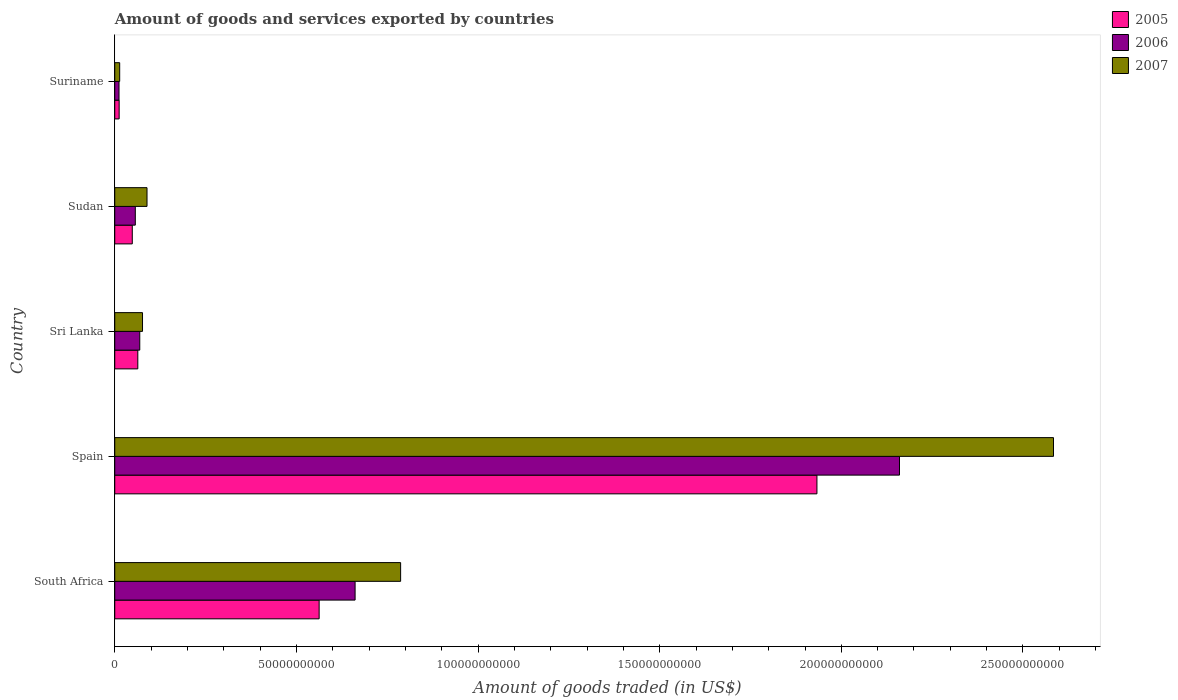How many different coloured bars are there?
Offer a very short reply. 3. Are the number of bars per tick equal to the number of legend labels?
Offer a terse response. Yes. Are the number of bars on each tick of the Y-axis equal?
Make the answer very short. Yes. What is the label of the 4th group of bars from the top?
Your response must be concise. Spain. In how many cases, is the number of bars for a given country not equal to the number of legend labels?
Your answer should be compact. 0. What is the total amount of goods and services exported in 2007 in Spain?
Provide a short and direct response. 2.58e+11. Across all countries, what is the maximum total amount of goods and services exported in 2007?
Provide a succinct answer. 2.58e+11. Across all countries, what is the minimum total amount of goods and services exported in 2006?
Offer a very short reply. 1.17e+09. In which country was the total amount of goods and services exported in 2005 minimum?
Provide a succinct answer. Suriname. What is the total total amount of goods and services exported in 2006 in the graph?
Provide a succinct answer. 2.96e+11. What is the difference between the total amount of goods and services exported in 2006 in Sri Lanka and that in Suriname?
Your answer should be compact. 5.71e+09. What is the difference between the total amount of goods and services exported in 2005 in South Africa and the total amount of goods and services exported in 2007 in Suriname?
Keep it short and to the point. 5.49e+1. What is the average total amount of goods and services exported in 2007 per country?
Make the answer very short. 7.10e+1. What is the difference between the total amount of goods and services exported in 2005 and total amount of goods and services exported in 2007 in Suriname?
Ensure brevity in your answer.  -1.48e+08. What is the ratio of the total amount of goods and services exported in 2007 in South Africa to that in Suriname?
Provide a short and direct response. 57.9. Is the difference between the total amount of goods and services exported in 2005 in Sri Lanka and Suriname greater than the difference between the total amount of goods and services exported in 2007 in Sri Lanka and Suriname?
Provide a short and direct response. No. What is the difference between the highest and the second highest total amount of goods and services exported in 2007?
Your answer should be very brief. 1.80e+11. What is the difference between the highest and the lowest total amount of goods and services exported in 2005?
Provide a succinct answer. 1.92e+11. Is the sum of the total amount of goods and services exported in 2007 in Spain and Suriname greater than the maximum total amount of goods and services exported in 2005 across all countries?
Provide a short and direct response. Yes. What does the 3rd bar from the top in Suriname represents?
Provide a succinct answer. 2005. What does the 2nd bar from the bottom in Sudan represents?
Your answer should be compact. 2006. Is it the case that in every country, the sum of the total amount of goods and services exported in 2007 and total amount of goods and services exported in 2006 is greater than the total amount of goods and services exported in 2005?
Provide a succinct answer. Yes. Are all the bars in the graph horizontal?
Provide a succinct answer. Yes. How many countries are there in the graph?
Your answer should be compact. 5. What is the difference between two consecutive major ticks on the X-axis?
Ensure brevity in your answer.  5.00e+1. Are the values on the major ticks of X-axis written in scientific E-notation?
Offer a very short reply. No. Where does the legend appear in the graph?
Keep it short and to the point. Top right. How are the legend labels stacked?
Provide a succinct answer. Vertical. What is the title of the graph?
Make the answer very short. Amount of goods and services exported by countries. What is the label or title of the X-axis?
Offer a very short reply. Amount of goods traded (in US$). What is the Amount of goods traded (in US$) of 2005 in South Africa?
Your answer should be compact. 5.63e+1. What is the Amount of goods traded (in US$) in 2006 in South Africa?
Offer a terse response. 6.62e+1. What is the Amount of goods traded (in US$) of 2007 in South Africa?
Provide a succinct answer. 7.87e+1. What is the Amount of goods traded (in US$) in 2005 in Spain?
Ensure brevity in your answer.  1.93e+11. What is the Amount of goods traded (in US$) in 2006 in Spain?
Keep it short and to the point. 2.16e+11. What is the Amount of goods traded (in US$) of 2007 in Spain?
Your answer should be very brief. 2.58e+11. What is the Amount of goods traded (in US$) in 2005 in Sri Lanka?
Your answer should be very brief. 6.35e+09. What is the Amount of goods traded (in US$) of 2006 in Sri Lanka?
Your answer should be compact. 6.88e+09. What is the Amount of goods traded (in US$) of 2007 in Sri Lanka?
Your answer should be compact. 7.64e+09. What is the Amount of goods traded (in US$) of 2005 in Sudan?
Keep it short and to the point. 4.82e+09. What is the Amount of goods traded (in US$) in 2006 in Sudan?
Your answer should be very brief. 5.66e+09. What is the Amount of goods traded (in US$) of 2007 in Sudan?
Your answer should be very brief. 8.88e+09. What is the Amount of goods traded (in US$) of 2005 in Suriname?
Offer a terse response. 1.21e+09. What is the Amount of goods traded (in US$) of 2006 in Suriname?
Your answer should be compact. 1.17e+09. What is the Amount of goods traded (in US$) of 2007 in Suriname?
Give a very brief answer. 1.36e+09. Across all countries, what is the maximum Amount of goods traded (in US$) in 2005?
Your answer should be compact. 1.93e+11. Across all countries, what is the maximum Amount of goods traded (in US$) of 2006?
Ensure brevity in your answer.  2.16e+11. Across all countries, what is the maximum Amount of goods traded (in US$) in 2007?
Ensure brevity in your answer.  2.58e+11. Across all countries, what is the minimum Amount of goods traded (in US$) of 2005?
Keep it short and to the point. 1.21e+09. Across all countries, what is the minimum Amount of goods traded (in US$) in 2006?
Ensure brevity in your answer.  1.17e+09. Across all countries, what is the minimum Amount of goods traded (in US$) of 2007?
Offer a very short reply. 1.36e+09. What is the total Amount of goods traded (in US$) in 2005 in the graph?
Your answer should be very brief. 2.62e+11. What is the total Amount of goods traded (in US$) in 2006 in the graph?
Your answer should be compact. 2.96e+11. What is the total Amount of goods traded (in US$) in 2007 in the graph?
Your response must be concise. 3.55e+11. What is the difference between the Amount of goods traded (in US$) of 2005 in South Africa and that in Spain?
Your answer should be compact. -1.37e+11. What is the difference between the Amount of goods traded (in US$) of 2006 in South Africa and that in Spain?
Offer a terse response. -1.50e+11. What is the difference between the Amount of goods traded (in US$) in 2007 in South Africa and that in Spain?
Your answer should be very brief. -1.80e+11. What is the difference between the Amount of goods traded (in US$) of 2005 in South Africa and that in Sri Lanka?
Your answer should be compact. 4.99e+1. What is the difference between the Amount of goods traded (in US$) of 2006 in South Africa and that in Sri Lanka?
Offer a very short reply. 5.93e+1. What is the difference between the Amount of goods traded (in US$) of 2007 in South Africa and that in Sri Lanka?
Keep it short and to the point. 7.11e+1. What is the difference between the Amount of goods traded (in US$) in 2005 in South Africa and that in Sudan?
Offer a very short reply. 5.14e+1. What is the difference between the Amount of goods traded (in US$) in 2006 in South Africa and that in Sudan?
Keep it short and to the point. 6.05e+1. What is the difference between the Amount of goods traded (in US$) of 2007 in South Africa and that in Sudan?
Give a very brief answer. 6.98e+1. What is the difference between the Amount of goods traded (in US$) of 2005 in South Africa and that in Suriname?
Your response must be concise. 5.50e+1. What is the difference between the Amount of goods traded (in US$) of 2006 in South Africa and that in Suriname?
Ensure brevity in your answer.  6.50e+1. What is the difference between the Amount of goods traded (in US$) in 2007 in South Africa and that in Suriname?
Your answer should be compact. 7.73e+1. What is the difference between the Amount of goods traded (in US$) in 2005 in Spain and that in Sri Lanka?
Ensure brevity in your answer.  1.87e+11. What is the difference between the Amount of goods traded (in US$) of 2006 in Spain and that in Sri Lanka?
Your answer should be very brief. 2.09e+11. What is the difference between the Amount of goods traded (in US$) of 2007 in Spain and that in Sri Lanka?
Make the answer very short. 2.51e+11. What is the difference between the Amount of goods traded (in US$) of 2005 in Spain and that in Sudan?
Keep it short and to the point. 1.88e+11. What is the difference between the Amount of goods traded (in US$) of 2006 in Spain and that in Sudan?
Make the answer very short. 2.10e+11. What is the difference between the Amount of goods traded (in US$) of 2007 in Spain and that in Sudan?
Provide a short and direct response. 2.50e+11. What is the difference between the Amount of goods traded (in US$) in 2005 in Spain and that in Suriname?
Offer a terse response. 1.92e+11. What is the difference between the Amount of goods traded (in US$) of 2006 in Spain and that in Suriname?
Give a very brief answer. 2.15e+11. What is the difference between the Amount of goods traded (in US$) in 2007 in Spain and that in Suriname?
Your response must be concise. 2.57e+11. What is the difference between the Amount of goods traded (in US$) of 2005 in Sri Lanka and that in Sudan?
Your answer should be compact. 1.52e+09. What is the difference between the Amount of goods traded (in US$) of 2006 in Sri Lanka and that in Sudan?
Provide a short and direct response. 1.23e+09. What is the difference between the Amount of goods traded (in US$) of 2007 in Sri Lanka and that in Sudan?
Ensure brevity in your answer.  -1.24e+09. What is the difference between the Amount of goods traded (in US$) in 2005 in Sri Lanka and that in Suriname?
Give a very brief answer. 5.14e+09. What is the difference between the Amount of goods traded (in US$) of 2006 in Sri Lanka and that in Suriname?
Your answer should be very brief. 5.71e+09. What is the difference between the Amount of goods traded (in US$) in 2007 in Sri Lanka and that in Suriname?
Make the answer very short. 6.28e+09. What is the difference between the Amount of goods traded (in US$) of 2005 in Sudan and that in Suriname?
Give a very brief answer. 3.61e+09. What is the difference between the Amount of goods traded (in US$) of 2006 in Sudan and that in Suriname?
Make the answer very short. 4.48e+09. What is the difference between the Amount of goods traded (in US$) of 2007 in Sudan and that in Suriname?
Provide a succinct answer. 7.52e+09. What is the difference between the Amount of goods traded (in US$) of 2005 in South Africa and the Amount of goods traded (in US$) of 2006 in Spain?
Your answer should be compact. -1.60e+11. What is the difference between the Amount of goods traded (in US$) in 2005 in South Africa and the Amount of goods traded (in US$) in 2007 in Spain?
Your answer should be very brief. -2.02e+11. What is the difference between the Amount of goods traded (in US$) of 2006 in South Africa and the Amount of goods traded (in US$) of 2007 in Spain?
Offer a very short reply. -1.92e+11. What is the difference between the Amount of goods traded (in US$) in 2005 in South Africa and the Amount of goods traded (in US$) in 2006 in Sri Lanka?
Offer a terse response. 4.94e+1. What is the difference between the Amount of goods traded (in US$) of 2005 in South Africa and the Amount of goods traded (in US$) of 2007 in Sri Lanka?
Make the answer very short. 4.86e+1. What is the difference between the Amount of goods traded (in US$) in 2006 in South Africa and the Amount of goods traded (in US$) in 2007 in Sri Lanka?
Offer a very short reply. 5.85e+1. What is the difference between the Amount of goods traded (in US$) in 2005 in South Africa and the Amount of goods traded (in US$) in 2006 in Sudan?
Your response must be concise. 5.06e+1. What is the difference between the Amount of goods traded (in US$) in 2005 in South Africa and the Amount of goods traded (in US$) in 2007 in Sudan?
Offer a terse response. 4.74e+1. What is the difference between the Amount of goods traded (in US$) in 2006 in South Africa and the Amount of goods traded (in US$) in 2007 in Sudan?
Provide a short and direct response. 5.73e+1. What is the difference between the Amount of goods traded (in US$) in 2005 in South Africa and the Amount of goods traded (in US$) in 2006 in Suriname?
Provide a succinct answer. 5.51e+1. What is the difference between the Amount of goods traded (in US$) of 2005 in South Africa and the Amount of goods traded (in US$) of 2007 in Suriname?
Make the answer very short. 5.49e+1. What is the difference between the Amount of goods traded (in US$) of 2006 in South Africa and the Amount of goods traded (in US$) of 2007 in Suriname?
Your answer should be very brief. 6.48e+1. What is the difference between the Amount of goods traded (in US$) in 2005 in Spain and the Amount of goods traded (in US$) in 2006 in Sri Lanka?
Keep it short and to the point. 1.86e+11. What is the difference between the Amount of goods traded (in US$) of 2005 in Spain and the Amount of goods traded (in US$) of 2007 in Sri Lanka?
Provide a short and direct response. 1.86e+11. What is the difference between the Amount of goods traded (in US$) in 2006 in Spain and the Amount of goods traded (in US$) in 2007 in Sri Lanka?
Offer a terse response. 2.08e+11. What is the difference between the Amount of goods traded (in US$) of 2005 in Spain and the Amount of goods traded (in US$) of 2006 in Sudan?
Keep it short and to the point. 1.88e+11. What is the difference between the Amount of goods traded (in US$) in 2005 in Spain and the Amount of goods traded (in US$) in 2007 in Sudan?
Provide a short and direct response. 1.84e+11. What is the difference between the Amount of goods traded (in US$) of 2006 in Spain and the Amount of goods traded (in US$) of 2007 in Sudan?
Ensure brevity in your answer.  2.07e+11. What is the difference between the Amount of goods traded (in US$) of 2005 in Spain and the Amount of goods traded (in US$) of 2006 in Suriname?
Ensure brevity in your answer.  1.92e+11. What is the difference between the Amount of goods traded (in US$) in 2005 in Spain and the Amount of goods traded (in US$) in 2007 in Suriname?
Your response must be concise. 1.92e+11. What is the difference between the Amount of goods traded (in US$) of 2006 in Spain and the Amount of goods traded (in US$) of 2007 in Suriname?
Give a very brief answer. 2.15e+11. What is the difference between the Amount of goods traded (in US$) in 2005 in Sri Lanka and the Amount of goods traded (in US$) in 2006 in Sudan?
Offer a terse response. 6.90e+08. What is the difference between the Amount of goods traded (in US$) of 2005 in Sri Lanka and the Amount of goods traded (in US$) of 2007 in Sudan?
Provide a succinct answer. -2.53e+09. What is the difference between the Amount of goods traded (in US$) of 2006 in Sri Lanka and the Amount of goods traded (in US$) of 2007 in Sudan?
Provide a short and direct response. -2.00e+09. What is the difference between the Amount of goods traded (in US$) of 2005 in Sri Lanka and the Amount of goods traded (in US$) of 2006 in Suriname?
Ensure brevity in your answer.  5.17e+09. What is the difference between the Amount of goods traded (in US$) of 2005 in Sri Lanka and the Amount of goods traded (in US$) of 2007 in Suriname?
Ensure brevity in your answer.  4.99e+09. What is the difference between the Amount of goods traded (in US$) in 2006 in Sri Lanka and the Amount of goods traded (in US$) in 2007 in Suriname?
Give a very brief answer. 5.52e+09. What is the difference between the Amount of goods traded (in US$) in 2005 in Sudan and the Amount of goods traded (in US$) in 2006 in Suriname?
Give a very brief answer. 3.65e+09. What is the difference between the Amount of goods traded (in US$) in 2005 in Sudan and the Amount of goods traded (in US$) in 2007 in Suriname?
Give a very brief answer. 3.47e+09. What is the difference between the Amount of goods traded (in US$) in 2006 in Sudan and the Amount of goods traded (in US$) in 2007 in Suriname?
Offer a terse response. 4.30e+09. What is the average Amount of goods traded (in US$) in 2005 per country?
Make the answer very short. 5.24e+1. What is the average Amount of goods traded (in US$) in 2006 per country?
Your answer should be compact. 5.92e+1. What is the average Amount of goods traded (in US$) of 2007 per country?
Provide a succinct answer. 7.10e+1. What is the difference between the Amount of goods traded (in US$) in 2005 and Amount of goods traded (in US$) in 2006 in South Africa?
Make the answer very short. -9.90e+09. What is the difference between the Amount of goods traded (in US$) of 2005 and Amount of goods traded (in US$) of 2007 in South Africa?
Offer a terse response. -2.24e+1. What is the difference between the Amount of goods traded (in US$) of 2006 and Amount of goods traded (in US$) of 2007 in South Africa?
Give a very brief answer. -1.25e+1. What is the difference between the Amount of goods traded (in US$) of 2005 and Amount of goods traded (in US$) of 2006 in Spain?
Provide a short and direct response. -2.27e+1. What is the difference between the Amount of goods traded (in US$) of 2005 and Amount of goods traded (in US$) of 2007 in Spain?
Offer a very short reply. -6.51e+1. What is the difference between the Amount of goods traded (in US$) of 2006 and Amount of goods traded (in US$) of 2007 in Spain?
Offer a terse response. -4.24e+1. What is the difference between the Amount of goods traded (in US$) of 2005 and Amount of goods traded (in US$) of 2006 in Sri Lanka?
Provide a short and direct response. -5.36e+08. What is the difference between the Amount of goods traded (in US$) in 2005 and Amount of goods traded (in US$) in 2007 in Sri Lanka?
Ensure brevity in your answer.  -1.29e+09. What is the difference between the Amount of goods traded (in US$) in 2006 and Amount of goods traded (in US$) in 2007 in Sri Lanka?
Your response must be concise. -7.57e+08. What is the difference between the Amount of goods traded (in US$) of 2005 and Amount of goods traded (in US$) of 2006 in Sudan?
Provide a succinct answer. -8.32e+08. What is the difference between the Amount of goods traded (in US$) of 2005 and Amount of goods traded (in US$) of 2007 in Sudan?
Keep it short and to the point. -4.05e+09. What is the difference between the Amount of goods traded (in US$) in 2006 and Amount of goods traded (in US$) in 2007 in Sudan?
Make the answer very short. -3.22e+09. What is the difference between the Amount of goods traded (in US$) of 2005 and Amount of goods traded (in US$) of 2006 in Suriname?
Offer a very short reply. 3.70e+07. What is the difference between the Amount of goods traded (in US$) of 2005 and Amount of goods traded (in US$) of 2007 in Suriname?
Your answer should be compact. -1.48e+08. What is the difference between the Amount of goods traded (in US$) of 2006 and Amount of goods traded (in US$) of 2007 in Suriname?
Make the answer very short. -1.84e+08. What is the ratio of the Amount of goods traded (in US$) of 2005 in South Africa to that in Spain?
Give a very brief answer. 0.29. What is the ratio of the Amount of goods traded (in US$) of 2006 in South Africa to that in Spain?
Keep it short and to the point. 0.31. What is the ratio of the Amount of goods traded (in US$) in 2007 in South Africa to that in Spain?
Offer a very short reply. 0.3. What is the ratio of the Amount of goods traded (in US$) in 2005 in South Africa to that in Sri Lanka?
Your answer should be compact. 8.86. What is the ratio of the Amount of goods traded (in US$) of 2006 in South Africa to that in Sri Lanka?
Keep it short and to the point. 9.61. What is the ratio of the Amount of goods traded (in US$) of 2007 in South Africa to that in Sri Lanka?
Your response must be concise. 10.3. What is the ratio of the Amount of goods traded (in US$) of 2005 in South Africa to that in Sudan?
Your answer should be very brief. 11.66. What is the ratio of the Amount of goods traded (in US$) of 2006 in South Africa to that in Sudan?
Make the answer very short. 11.7. What is the ratio of the Amount of goods traded (in US$) of 2007 in South Africa to that in Sudan?
Your answer should be very brief. 8.86. What is the ratio of the Amount of goods traded (in US$) of 2005 in South Africa to that in Suriname?
Your answer should be compact. 46.44. What is the ratio of the Amount of goods traded (in US$) in 2006 in South Africa to that in Suriname?
Offer a terse response. 56.33. What is the ratio of the Amount of goods traded (in US$) of 2007 in South Africa to that in Suriname?
Give a very brief answer. 57.9. What is the ratio of the Amount of goods traded (in US$) in 2005 in Spain to that in Sri Lanka?
Keep it short and to the point. 30.45. What is the ratio of the Amount of goods traded (in US$) of 2006 in Spain to that in Sri Lanka?
Ensure brevity in your answer.  31.39. What is the ratio of the Amount of goods traded (in US$) of 2007 in Spain to that in Sri Lanka?
Provide a succinct answer. 33.82. What is the ratio of the Amount of goods traded (in US$) in 2005 in Spain to that in Sudan?
Your answer should be very brief. 40.06. What is the ratio of the Amount of goods traded (in US$) in 2006 in Spain to that in Sudan?
Provide a succinct answer. 38.19. What is the ratio of the Amount of goods traded (in US$) in 2007 in Spain to that in Sudan?
Offer a very short reply. 29.1. What is the ratio of the Amount of goods traded (in US$) of 2005 in Spain to that in Suriname?
Keep it short and to the point. 159.54. What is the ratio of the Amount of goods traded (in US$) in 2006 in Spain to that in Suriname?
Your response must be concise. 183.92. What is the ratio of the Amount of goods traded (in US$) of 2007 in Spain to that in Suriname?
Make the answer very short. 190.14. What is the ratio of the Amount of goods traded (in US$) of 2005 in Sri Lanka to that in Sudan?
Provide a short and direct response. 1.32. What is the ratio of the Amount of goods traded (in US$) in 2006 in Sri Lanka to that in Sudan?
Your answer should be very brief. 1.22. What is the ratio of the Amount of goods traded (in US$) in 2007 in Sri Lanka to that in Sudan?
Your answer should be very brief. 0.86. What is the ratio of the Amount of goods traded (in US$) in 2005 in Sri Lanka to that in Suriname?
Make the answer very short. 5.24. What is the ratio of the Amount of goods traded (in US$) in 2006 in Sri Lanka to that in Suriname?
Keep it short and to the point. 5.86. What is the ratio of the Amount of goods traded (in US$) in 2007 in Sri Lanka to that in Suriname?
Offer a very short reply. 5.62. What is the ratio of the Amount of goods traded (in US$) in 2005 in Sudan to that in Suriname?
Ensure brevity in your answer.  3.98. What is the ratio of the Amount of goods traded (in US$) in 2006 in Sudan to that in Suriname?
Offer a terse response. 4.82. What is the ratio of the Amount of goods traded (in US$) in 2007 in Sudan to that in Suriname?
Your answer should be compact. 6.53. What is the difference between the highest and the second highest Amount of goods traded (in US$) in 2005?
Give a very brief answer. 1.37e+11. What is the difference between the highest and the second highest Amount of goods traded (in US$) of 2006?
Your answer should be compact. 1.50e+11. What is the difference between the highest and the second highest Amount of goods traded (in US$) of 2007?
Provide a short and direct response. 1.80e+11. What is the difference between the highest and the lowest Amount of goods traded (in US$) of 2005?
Your answer should be very brief. 1.92e+11. What is the difference between the highest and the lowest Amount of goods traded (in US$) in 2006?
Provide a short and direct response. 2.15e+11. What is the difference between the highest and the lowest Amount of goods traded (in US$) in 2007?
Keep it short and to the point. 2.57e+11. 